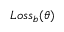Convert formula to latex. <formula><loc_0><loc_0><loc_500><loc_500>L o s s _ { b } ( \theta )</formula> 